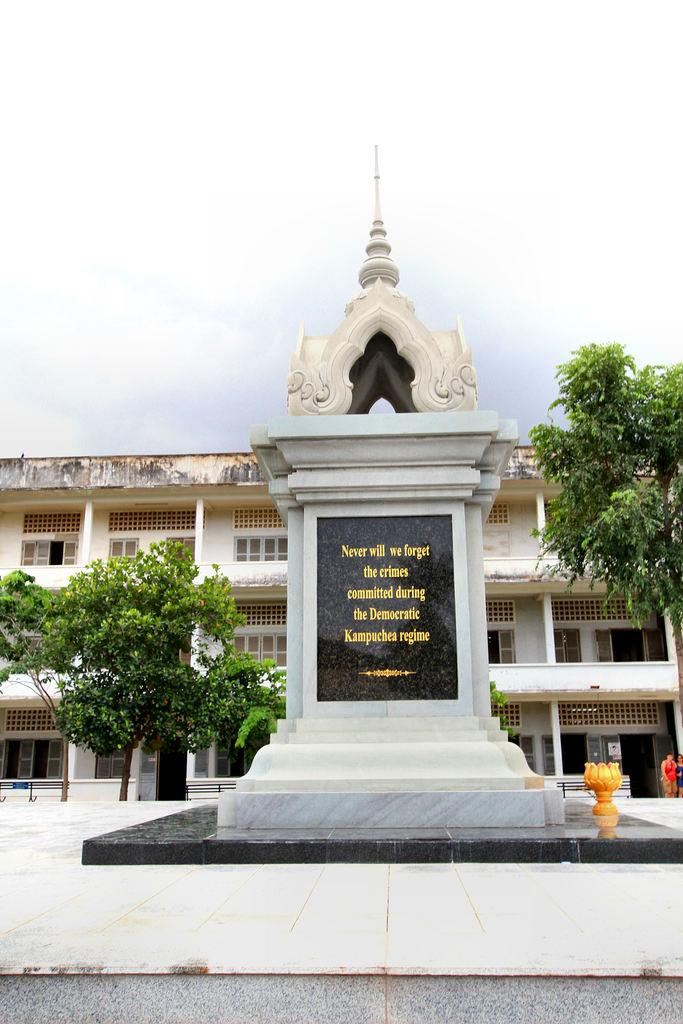What is the main subject in the image? There is a memorial stone in the image. What can be seen in the background of the image? There is a building, trees, two people, and the sky visible in the background of the image. What type of skin condition can be seen on the memorial stone in the image? There is no skin condition present on the memorial stone, as it is a stone structure and not a living organism. 